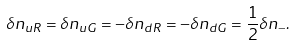<formula> <loc_0><loc_0><loc_500><loc_500>\delta n _ { u R } = \delta n _ { u G } = - \delta n _ { d R } = - \delta n _ { d G } = \frac { 1 } { 2 } \delta n _ { - } .</formula> 